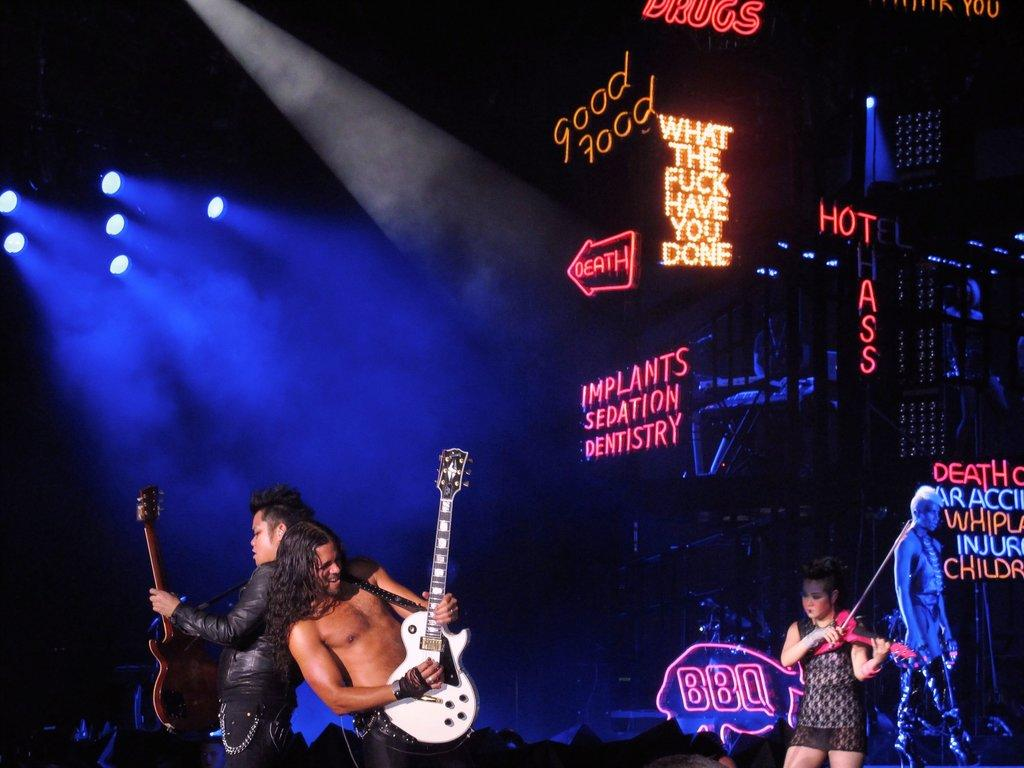Where was the image taken? The image was taken on a stage. What are the people in the image doing? The people in the image are performing, and they are playing music instruments. What can be seen in the background of the image? There is a banner with lightnings in the background. What type of basket is being used by the performers in the image? There is no basket present in the image. Can you describe the patch on the sweater worn by one of the performers? There is no sweater or patch visible in the image; the performers are playing music instruments. 